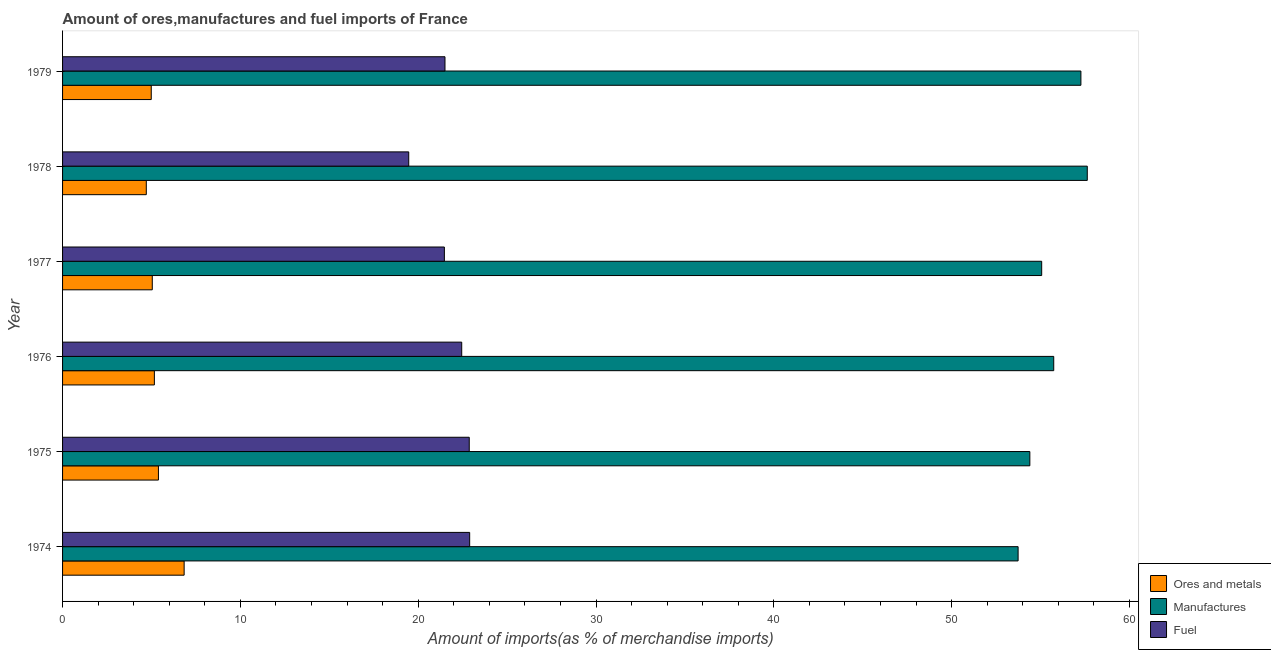How many different coloured bars are there?
Ensure brevity in your answer.  3. Are the number of bars per tick equal to the number of legend labels?
Your answer should be very brief. Yes. Are the number of bars on each tick of the Y-axis equal?
Provide a succinct answer. Yes. What is the label of the 2nd group of bars from the top?
Your answer should be very brief. 1978. What is the percentage of ores and metals imports in 1979?
Ensure brevity in your answer.  4.99. Across all years, what is the maximum percentage of fuel imports?
Provide a succinct answer. 22.89. Across all years, what is the minimum percentage of ores and metals imports?
Your answer should be compact. 4.71. In which year was the percentage of fuel imports maximum?
Make the answer very short. 1974. In which year was the percentage of fuel imports minimum?
Make the answer very short. 1978. What is the total percentage of manufactures imports in the graph?
Your answer should be very brief. 333.82. What is the difference between the percentage of fuel imports in 1977 and that in 1979?
Provide a short and direct response. -0.03. What is the difference between the percentage of fuel imports in 1978 and the percentage of ores and metals imports in 1975?
Give a very brief answer. 14.08. What is the average percentage of ores and metals imports per year?
Provide a short and direct response. 5.36. In the year 1976, what is the difference between the percentage of ores and metals imports and percentage of manufactures imports?
Keep it short and to the point. -50.58. In how many years, is the percentage of fuel imports greater than 52 %?
Ensure brevity in your answer.  0. What is the ratio of the percentage of fuel imports in 1974 to that in 1977?
Provide a short and direct response. 1.07. Is the percentage of ores and metals imports in 1976 less than that in 1979?
Your answer should be compact. No. What is the difference between the highest and the second highest percentage of ores and metals imports?
Provide a succinct answer. 1.45. What is the difference between the highest and the lowest percentage of ores and metals imports?
Keep it short and to the point. 2.13. What does the 2nd bar from the top in 1978 represents?
Make the answer very short. Manufactures. What does the 1st bar from the bottom in 1977 represents?
Your response must be concise. Ores and metals. Is it the case that in every year, the sum of the percentage of ores and metals imports and percentage of manufactures imports is greater than the percentage of fuel imports?
Your answer should be very brief. Yes. How many bars are there?
Offer a very short reply. 18. How many years are there in the graph?
Provide a succinct answer. 6. What is the difference between two consecutive major ticks on the X-axis?
Make the answer very short. 10. Does the graph contain grids?
Make the answer very short. No. How are the legend labels stacked?
Provide a succinct answer. Vertical. What is the title of the graph?
Your response must be concise. Amount of ores,manufactures and fuel imports of France. What is the label or title of the X-axis?
Offer a terse response. Amount of imports(as % of merchandise imports). What is the Amount of imports(as % of merchandise imports) of Ores and metals in 1974?
Give a very brief answer. 6.84. What is the Amount of imports(as % of merchandise imports) of Manufactures in 1974?
Provide a short and direct response. 53.74. What is the Amount of imports(as % of merchandise imports) of Fuel in 1974?
Your answer should be compact. 22.89. What is the Amount of imports(as % of merchandise imports) of Ores and metals in 1975?
Your answer should be very brief. 5.39. What is the Amount of imports(as % of merchandise imports) of Manufactures in 1975?
Make the answer very short. 54.4. What is the Amount of imports(as % of merchandise imports) of Fuel in 1975?
Provide a succinct answer. 22.87. What is the Amount of imports(as % of merchandise imports) of Ores and metals in 1976?
Your response must be concise. 5.16. What is the Amount of imports(as % of merchandise imports) of Manufactures in 1976?
Make the answer very short. 55.74. What is the Amount of imports(as % of merchandise imports) of Fuel in 1976?
Keep it short and to the point. 22.45. What is the Amount of imports(as % of merchandise imports) in Ores and metals in 1977?
Offer a very short reply. 5.05. What is the Amount of imports(as % of merchandise imports) of Manufactures in 1977?
Ensure brevity in your answer.  55.06. What is the Amount of imports(as % of merchandise imports) in Fuel in 1977?
Your answer should be very brief. 21.47. What is the Amount of imports(as % of merchandise imports) in Ores and metals in 1978?
Your answer should be very brief. 4.71. What is the Amount of imports(as % of merchandise imports) of Manufactures in 1978?
Offer a terse response. 57.63. What is the Amount of imports(as % of merchandise imports) in Fuel in 1978?
Ensure brevity in your answer.  19.47. What is the Amount of imports(as % of merchandise imports) in Ores and metals in 1979?
Provide a short and direct response. 4.99. What is the Amount of imports(as % of merchandise imports) of Manufactures in 1979?
Your answer should be very brief. 57.27. What is the Amount of imports(as % of merchandise imports) in Fuel in 1979?
Give a very brief answer. 21.51. Across all years, what is the maximum Amount of imports(as % of merchandise imports) in Ores and metals?
Make the answer very short. 6.84. Across all years, what is the maximum Amount of imports(as % of merchandise imports) in Manufactures?
Make the answer very short. 57.63. Across all years, what is the maximum Amount of imports(as % of merchandise imports) of Fuel?
Make the answer very short. 22.89. Across all years, what is the minimum Amount of imports(as % of merchandise imports) of Ores and metals?
Ensure brevity in your answer.  4.71. Across all years, what is the minimum Amount of imports(as % of merchandise imports) in Manufactures?
Give a very brief answer. 53.74. Across all years, what is the minimum Amount of imports(as % of merchandise imports) in Fuel?
Offer a very short reply. 19.47. What is the total Amount of imports(as % of merchandise imports) in Ores and metals in the graph?
Ensure brevity in your answer.  32.13. What is the total Amount of imports(as % of merchandise imports) of Manufactures in the graph?
Your answer should be very brief. 333.82. What is the total Amount of imports(as % of merchandise imports) of Fuel in the graph?
Offer a terse response. 130.65. What is the difference between the Amount of imports(as % of merchandise imports) in Ores and metals in 1974 and that in 1975?
Provide a short and direct response. 1.45. What is the difference between the Amount of imports(as % of merchandise imports) of Manufactures in 1974 and that in 1975?
Provide a short and direct response. -0.66. What is the difference between the Amount of imports(as % of merchandise imports) of Fuel in 1974 and that in 1975?
Offer a terse response. 0.02. What is the difference between the Amount of imports(as % of merchandise imports) in Ores and metals in 1974 and that in 1976?
Give a very brief answer. 1.67. What is the difference between the Amount of imports(as % of merchandise imports) of Manufactures in 1974 and that in 1976?
Your answer should be compact. -2. What is the difference between the Amount of imports(as % of merchandise imports) of Fuel in 1974 and that in 1976?
Offer a terse response. 0.45. What is the difference between the Amount of imports(as % of merchandise imports) in Ores and metals in 1974 and that in 1977?
Your response must be concise. 1.79. What is the difference between the Amount of imports(as % of merchandise imports) in Manufactures in 1974 and that in 1977?
Your answer should be compact. -1.33. What is the difference between the Amount of imports(as % of merchandise imports) in Fuel in 1974 and that in 1977?
Offer a terse response. 1.42. What is the difference between the Amount of imports(as % of merchandise imports) of Ores and metals in 1974 and that in 1978?
Provide a short and direct response. 2.13. What is the difference between the Amount of imports(as % of merchandise imports) in Manufactures in 1974 and that in 1978?
Offer a terse response. -3.89. What is the difference between the Amount of imports(as % of merchandise imports) in Fuel in 1974 and that in 1978?
Offer a very short reply. 3.43. What is the difference between the Amount of imports(as % of merchandise imports) of Ores and metals in 1974 and that in 1979?
Give a very brief answer. 1.85. What is the difference between the Amount of imports(as % of merchandise imports) in Manufactures in 1974 and that in 1979?
Keep it short and to the point. -3.53. What is the difference between the Amount of imports(as % of merchandise imports) of Fuel in 1974 and that in 1979?
Provide a succinct answer. 1.39. What is the difference between the Amount of imports(as % of merchandise imports) in Ores and metals in 1975 and that in 1976?
Provide a short and direct response. 0.23. What is the difference between the Amount of imports(as % of merchandise imports) of Manufactures in 1975 and that in 1976?
Your response must be concise. -1.34. What is the difference between the Amount of imports(as % of merchandise imports) in Fuel in 1975 and that in 1976?
Your answer should be very brief. 0.42. What is the difference between the Amount of imports(as % of merchandise imports) of Ores and metals in 1975 and that in 1977?
Your response must be concise. 0.35. What is the difference between the Amount of imports(as % of merchandise imports) in Manufactures in 1975 and that in 1977?
Your answer should be very brief. -0.67. What is the difference between the Amount of imports(as % of merchandise imports) of Fuel in 1975 and that in 1977?
Provide a short and direct response. 1.4. What is the difference between the Amount of imports(as % of merchandise imports) of Ores and metals in 1975 and that in 1978?
Your response must be concise. 0.68. What is the difference between the Amount of imports(as % of merchandise imports) of Manufactures in 1975 and that in 1978?
Keep it short and to the point. -3.23. What is the difference between the Amount of imports(as % of merchandise imports) of Fuel in 1975 and that in 1978?
Make the answer very short. 3.4. What is the difference between the Amount of imports(as % of merchandise imports) in Ores and metals in 1975 and that in 1979?
Offer a very short reply. 0.4. What is the difference between the Amount of imports(as % of merchandise imports) in Manufactures in 1975 and that in 1979?
Offer a very short reply. -2.87. What is the difference between the Amount of imports(as % of merchandise imports) of Fuel in 1975 and that in 1979?
Provide a short and direct response. 1.36. What is the difference between the Amount of imports(as % of merchandise imports) in Ores and metals in 1976 and that in 1977?
Provide a succinct answer. 0.12. What is the difference between the Amount of imports(as % of merchandise imports) in Manufactures in 1976 and that in 1977?
Offer a very short reply. 0.68. What is the difference between the Amount of imports(as % of merchandise imports) of Fuel in 1976 and that in 1977?
Ensure brevity in your answer.  0.98. What is the difference between the Amount of imports(as % of merchandise imports) in Ores and metals in 1976 and that in 1978?
Make the answer very short. 0.45. What is the difference between the Amount of imports(as % of merchandise imports) of Manufactures in 1976 and that in 1978?
Provide a succinct answer. -1.89. What is the difference between the Amount of imports(as % of merchandise imports) of Fuel in 1976 and that in 1978?
Your answer should be very brief. 2.98. What is the difference between the Amount of imports(as % of merchandise imports) of Ores and metals in 1976 and that in 1979?
Your answer should be compact. 0.18. What is the difference between the Amount of imports(as % of merchandise imports) of Manufactures in 1976 and that in 1979?
Give a very brief answer. -1.53. What is the difference between the Amount of imports(as % of merchandise imports) in Fuel in 1976 and that in 1979?
Give a very brief answer. 0.94. What is the difference between the Amount of imports(as % of merchandise imports) in Ores and metals in 1977 and that in 1978?
Your answer should be compact. 0.34. What is the difference between the Amount of imports(as % of merchandise imports) of Manufactures in 1977 and that in 1978?
Keep it short and to the point. -2.56. What is the difference between the Amount of imports(as % of merchandise imports) in Fuel in 1977 and that in 1978?
Offer a terse response. 2. What is the difference between the Amount of imports(as % of merchandise imports) of Ores and metals in 1977 and that in 1979?
Ensure brevity in your answer.  0.06. What is the difference between the Amount of imports(as % of merchandise imports) of Manufactures in 1977 and that in 1979?
Offer a very short reply. -2.21. What is the difference between the Amount of imports(as % of merchandise imports) in Fuel in 1977 and that in 1979?
Provide a succinct answer. -0.03. What is the difference between the Amount of imports(as % of merchandise imports) of Ores and metals in 1978 and that in 1979?
Keep it short and to the point. -0.28. What is the difference between the Amount of imports(as % of merchandise imports) in Manufactures in 1978 and that in 1979?
Provide a short and direct response. 0.36. What is the difference between the Amount of imports(as % of merchandise imports) in Fuel in 1978 and that in 1979?
Offer a very short reply. -2.04. What is the difference between the Amount of imports(as % of merchandise imports) of Ores and metals in 1974 and the Amount of imports(as % of merchandise imports) of Manufactures in 1975?
Offer a very short reply. -47.56. What is the difference between the Amount of imports(as % of merchandise imports) in Ores and metals in 1974 and the Amount of imports(as % of merchandise imports) in Fuel in 1975?
Make the answer very short. -16.03. What is the difference between the Amount of imports(as % of merchandise imports) of Manufactures in 1974 and the Amount of imports(as % of merchandise imports) of Fuel in 1975?
Offer a terse response. 30.87. What is the difference between the Amount of imports(as % of merchandise imports) in Ores and metals in 1974 and the Amount of imports(as % of merchandise imports) in Manufactures in 1976?
Offer a terse response. -48.9. What is the difference between the Amount of imports(as % of merchandise imports) in Ores and metals in 1974 and the Amount of imports(as % of merchandise imports) in Fuel in 1976?
Keep it short and to the point. -15.61. What is the difference between the Amount of imports(as % of merchandise imports) of Manufactures in 1974 and the Amount of imports(as % of merchandise imports) of Fuel in 1976?
Keep it short and to the point. 31.29. What is the difference between the Amount of imports(as % of merchandise imports) in Ores and metals in 1974 and the Amount of imports(as % of merchandise imports) in Manufactures in 1977?
Offer a very short reply. -48.22. What is the difference between the Amount of imports(as % of merchandise imports) in Ores and metals in 1974 and the Amount of imports(as % of merchandise imports) in Fuel in 1977?
Your response must be concise. -14.63. What is the difference between the Amount of imports(as % of merchandise imports) in Manufactures in 1974 and the Amount of imports(as % of merchandise imports) in Fuel in 1977?
Your answer should be compact. 32.26. What is the difference between the Amount of imports(as % of merchandise imports) in Ores and metals in 1974 and the Amount of imports(as % of merchandise imports) in Manufactures in 1978?
Offer a terse response. -50.79. What is the difference between the Amount of imports(as % of merchandise imports) in Ores and metals in 1974 and the Amount of imports(as % of merchandise imports) in Fuel in 1978?
Your response must be concise. -12.63. What is the difference between the Amount of imports(as % of merchandise imports) in Manufactures in 1974 and the Amount of imports(as % of merchandise imports) in Fuel in 1978?
Your response must be concise. 34.27. What is the difference between the Amount of imports(as % of merchandise imports) of Ores and metals in 1974 and the Amount of imports(as % of merchandise imports) of Manufactures in 1979?
Make the answer very short. -50.43. What is the difference between the Amount of imports(as % of merchandise imports) of Ores and metals in 1974 and the Amount of imports(as % of merchandise imports) of Fuel in 1979?
Give a very brief answer. -14.67. What is the difference between the Amount of imports(as % of merchandise imports) of Manufactures in 1974 and the Amount of imports(as % of merchandise imports) of Fuel in 1979?
Provide a succinct answer. 32.23. What is the difference between the Amount of imports(as % of merchandise imports) of Ores and metals in 1975 and the Amount of imports(as % of merchandise imports) of Manufactures in 1976?
Make the answer very short. -50.35. What is the difference between the Amount of imports(as % of merchandise imports) in Ores and metals in 1975 and the Amount of imports(as % of merchandise imports) in Fuel in 1976?
Your response must be concise. -17.06. What is the difference between the Amount of imports(as % of merchandise imports) in Manufactures in 1975 and the Amount of imports(as % of merchandise imports) in Fuel in 1976?
Your response must be concise. 31.95. What is the difference between the Amount of imports(as % of merchandise imports) in Ores and metals in 1975 and the Amount of imports(as % of merchandise imports) in Manufactures in 1977?
Your answer should be compact. -49.67. What is the difference between the Amount of imports(as % of merchandise imports) in Ores and metals in 1975 and the Amount of imports(as % of merchandise imports) in Fuel in 1977?
Keep it short and to the point. -16.08. What is the difference between the Amount of imports(as % of merchandise imports) of Manufactures in 1975 and the Amount of imports(as % of merchandise imports) of Fuel in 1977?
Make the answer very short. 32.92. What is the difference between the Amount of imports(as % of merchandise imports) in Ores and metals in 1975 and the Amount of imports(as % of merchandise imports) in Manufactures in 1978?
Make the answer very short. -52.23. What is the difference between the Amount of imports(as % of merchandise imports) of Ores and metals in 1975 and the Amount of imports(as % of merchandise imports) of Fuel in 1978?
Keep it short and to the point. -14.08. What is the difference between the Amount of imports(as % of merchandise imports) in Manufactures in 1975 and the Amount of imports(as % of merchandise imports) in Fuel in 1978?
Offer a terse response. 34.93. What is the difference between the Amount of imports(as % of merchandise imports) in Ores and metals in 1975 and the Amount of imports(as % of merchandise imports) in Manufactures in 1979?
Your response must be concise. -51.88. What is the difference between the Amount of imports(as % of merchandise imports) in Ores and metals in 1975 and the Amount of imports(as % of merchandise imports) in Fuel in 1979?
Offer a very short reply. -16.11. What is the difference between the Amount of imports(as % of merchandise imports) of Manufactures in 1975 and the Amount of imports(as % of merchandise imports) of Fuel in 1979?
Give a very brief answer. 32.89. What is the difference between the Amount of imports(as % of merchandise imports) in Ores and metals in 1976 and the Amount of imports(as % of merchandise imports) in Manufactures in 1977?
Keep it short and to the point. -49.9. What is the difference between the Amount of imports(as % of merchandise imports) in Ores and metals in 1976 and the Amount of imports(as % of merchandise imports) in Fuel in 1977?
Keep it short and to the point. -16.31. What is the difference between the Amount of imports(as % of merchandise imports) in Manufactures in 1976 and the Amount of imports(as % of merchandise imports) in Fuel in 1977?
Your answer should be compact. 34.27. What is the difference between the Amount of imports(as % of merchandise imports) of Ores and metals in 1976 and the Amount of imports(as % of merchandise imports) of Manufactures in 1978?
Your answer should be compact. -52.46. What is the difference between the Amount of imports(as % of merchandise imports) in Ores and metals in 1976 and the Amount of imports(as % of merchandise imports) in Fuel in 1978?
Ensure brevity in your answer.  -14.3. What is the difference between the Amount of imports(as % of merchandise imports) in Manufactures in 1976 and the Amount of imports(as % of merchandise imports) in Fuel in 1978?
Ensure brevity in your answer.  36.27. What is the difference between the Amount of imports(as % of merchandise imports) of Ores and metals in 1976 and the Amount of imports(as % of merchandise imports) of Manufactures in 1979?
Your answer should be compact. -52.1. What is the difference between the Amount of imports(as % of merchandise imports) in Ores and metals in 1976 and the Amount of imports(as % of merchandise imports) in Fuel in 1979?
Your answer should be very brief. -16.34. What is the difference between the Amount of imports(as % of merchandise imports) in Manufactures in 1976 and the Amount of imports(as % of merchandise imports) in Fuel in 1979?
Your answer should be very brief. 34.23. What is the difference between the Amount of imports(as % of merchandise imports) of Ores and metals in 1977 and the Amount of imports(as % of merchandise imports) of Manufactures in 1978?
Ensure brevity in your answer.  -52.58. What is the difference between the Amount of imports(as % of merchandise imports) of Ores and metals in 1977 and the Amount of imports(as % of merchandise imports) of Fuel in 1978?
Your answer should be compact. -14.42. What is the difference between the Amount of imports(as % of merchandise imports) of Manufactures in 1977 and the Amount of imports(as % of merchandise imports) of Fuel in 1978?
Your answer should be very brief. 35.59. What is the difference between the Amount of imports(as % of merchandise imports) of Ores and metals in 1977 and the Amount of imports(as % of merchandise imports) of Manufactures in 1979?
Make the answer very short. -52.22. What is the difference between the Amount of imports(as % of merchandise imports) of Ores and metals in 1977 and the Amount of imports(as % of merchandise imports) of Fuel in 1979?
Give a very brief answer. -16.46. What is the difference between the Amount of imports(as % of merchandise imports) in Manufactures in 1977 and the Amount of imports(as % of merchandise imports) in Fuel in 1979?
Offer a terse response. 33.56. What is the difference between the Amount of imports(as % of merchandise imports) of Ores and metals in 1978 and the Amount of imports(as % of merchandise imports) of Manufactures in 1979?
Make the answer very short. -52.56. What is the difference between the Amount of imports(as % of merchandise imports) in Ores and metals in 1978 and the Amount of imports(as % of merchandise imports) in Fuel in 1979?
Make the answer very short. -16.8. What is the difference between the Amount of imports(as % of merchandise imports) of Manufactures in 1978 and the Amount of imports(as % of merchandise imports) of Fuel in 1979?
Ensure brevity in your answer.  36.12. What is the average Amount of imports(as % of merchandise imports) of Ores and metals per year?
Ensure brevity in your answer.  5.36. What is the average Amount of imports(as % of merchandise imports) of Manufactures per year?
Your answer should be compact. 55.64. What is the average Amount of imports(as % of merchandise imports) in Fuel per year?
Your response must be concise. 21.78. In the year 1974, what is the difference between the Amount of imports(as % of merchandise imports) in Ores and metals and Amount of imports(as % of merchandise imports) in Manufactures?
Offer a very short reply. -46.9. In the year 1974, what is the difference between the Amount of imports(as % of merchandise imports) in Ores and metals and Amount of imports(as % of merchandise imports) in Fuel?
Offer a very short reply. -16.06. In the year 1974, what is the difference between the Amount of imports(as % of merchandise imports) of Manufactures and Amount of imports(as % of merchandise imports) of Fuel?
Your response must be concise. 30.84. In the year 1975, what is the difference between the Amount of imports(as % of merchandise imports) of Ores and metals and Amount of imports(as % of merchandise imports) of Manufactures?
Your answer should be compact. -49. In the year 1975, what is the difference between the Amount of imports(as % of merchandise imports) of Ores and metals and Amount of imports(as % of merchandise imports) of Fuel?
Give a very brief answer. -17.48. In the year 1975, what is the difference between the Amount of imports(as % of merchandise imports) of Manufactures and Amount of imports(as % of merchandise imports) of Fuel?
Keep it short and to the point. 31.53. In the year 1976, what is the difference between the Amount of imports(as % of merchandise imports) of Ores and metals and Amount of imports(as % of merchandise imports) of Manufactures?
Give a very brief answer. -50.58. In the year 1976, what is the difference between the Amount of imports(as % of merchandise imports) in Ores and metals and Amount of imports(as % of merchandise imports) in Fuel?
Provide a succinct answer. -17.28. In the year 1976, what is the difference between the Amount of imports(as % of merchandise imports) in Manufactures and Amount of imports(as % of merchandise imports) in Fuel?
Your answer should be compact. 33.29. In the year 1977, what is the difference between the Amount of imports(as % of merchandise imports) in Ores and metals and Amount of imports(as % of merchandise imports) in Manufactures?
Your answer should be compact. -50.02. In the year 1977, what is the difference between the Amount of imports(as % of merchandise imports) of Ores and metals and Amount of imports(as % of merchandise imports) of Fuel?
Your answer should be very brief. -16.43. In the year 1977, what is the difference between the Amount of imports(as % of merchandise imports) in Manufactures and Amount of imports(as % of merchandise imports) in Fuel?
Provide a succinct answer. 33.59. In the year 1978, what is the difference between the Amount of imports(as % of merchandise imports) in Ores and metals and Amount of imports(as % of merchandise imports) in Manufactures?
Ensure brevity in your answer.  -52.92. In the year 1978, what is the difference between the Amount of imports(as % of merchandise imports) of Ores and metals and Amount of imports(as % of merchandise imports) of Fuel?
Offer a terse response. -14.76. In the year 1978, what is the difference between the Amount of imports(as % of merchandise imports) of Manufactures and Amount of imports(as % of merchandise imports) of Fuel?
Offer a very short reply. 38.16. In the year 1979, what is the difference between the Amount of imports(as % of merchandise imports) of Ores and metals and Amount of imports(as % of merchandise imports) of Manufactures?
Make the answer very short. -52.28. In the year 1979, what is the difference between the Amount of imports(as % of merchandise imports) in Ores and metals and Amount of imports(as % of merchandise imports) in Fuel?
Your answer should be compact. -16.52. In the year 1979, what is the difference between the Amount of imports(as % of merchandise imports) in Manufactures and Amount of imports(as % of merchandise imports) in Fuel?
Your answer should be very brief. 35.76. What is the ratio of the Amount of imports(as % of merchandise imports) in Ores and metals in 1974 to that in 1975?
Your answer should be compact. 1.27. What is the ratio of the Amount of imports(as % of merchandise imports) of Manufactures in 1974 to that in 1975?
Make the answer very short. 0.99. What is the ratio of the Amount of imports(as % of merchandise imports) in Ores and metals in 1974 to that in 1976?
Ensure brevity in your answer.  1.32. What is the ratio of the Amount of imports(as % of merchandise imports) in Manufactures in 1974 to that in 1976?
Your answer should be very brief. 0.96. What is the ratio of the Amount of imports(as % of merchandise imports) of Fuel in 1974 to that in 1976?
Your answer should be very brief. 1.02. What is the ratio of the Amount of imports(as % of merchandise imports) in Ores and metals in 1974 to that in 1977?
Give a very brief answer. 1.35. What is the ratio of the Amount of imports(as % of merchandise imports) of Manufactures in 1974 to that in 1977?
Offer a very short reply. 0.98. What is the ratio of the Amount of imports(as % of merchandise imports) of Fuel in 1974 to that in 1977?
Give a very brief answer. 1.07. What is the ratio of the Amount of imports(as % of merchandise imports) in Ores and metals in 1974 to that in 1978?
Offer a terse response. 1.45. What is the ratio of the Amount of imports(as % of merchandise imports) of Manufactures in 1974 to that in 1978?
Give a very brief answer. 0.93. What is the ratio of the Amount of imports(as % of merchandise imports) in Fuel in 1974 to that in 1978?
Provide a short and direct response. 1.18. What is the ratio of the Amount of imports(as % of merchandise imports) in Ores and metals in 1974 to that in 1979?
Offer a very short reply. 1.37. What is the ratio of the Amount of imports(as % of merchandise imports) of Manufactures in 1974 to that in 1979?
Offer a very short reply. 0.94. What is the ratio of the Amount of imports(as % of merchandise imports) of Fuel in 1974 to that in 1979?
Your answer should be very brief. 1.06. What is the ratio of the Amount of imports(as % of merchandise imports) of Ores and metals in 1975 to that in 1976?
Make the answer very short. 1.04. What is the ratio of the Amount of imports(as % of merchandise imports) in Manufactures in 1975 to that in 1976?
Your answer should be compact. 0.98. What is the ratio of the Amount of imports(as % of merchandise imports) in Fuel in 1975 to that in 1976?
Offer a very short reply. 1.02. What is the ratio of the Amount of imports(as % of merchandise imports) of Ores and metals in 1975 to that in 1977?
Make the answer very short. 1.07. What is the ratio of the Amount of imports(as % of merchandise imports) in Manufactures in 1975 to that in 1977?
Give a very brief answer. 0.99. What is the ratio of the Amount of imports(as % of merchandise imports) of Fuel in 1975 to that in 1977?
Your answer should be compact. 1.07. What is the ratio of the Amount of imports(as % of merchandise imports) of Ores and metals in 1975 to that in 1978?
Your answer should be compact. 1.14. What is the ratio of the Amount of imports(as % of merchandise imports) of Manufactures in 1975 to that in 1978?
Offer a terse response. 0.94. What is the ratio of the Amount of imports(as % of merchandise imports) in Fuel in 1975 to that in 1978?
Your answer should be compact. 1.17. What is the ratio of the Amount of imports(as % of merchandise imports) in Ores and metals in 1975 to that in 1979?
Your answer should be very brief. 1.08. What is the ratio of the Amount of imports(as % of merchandise imports) in Manufactures in 1975 to that in 1979?
Keep it short and to the point. 0.95. What is the ratio of the Amount of imports(as % of merchandise imports) in Fuel in 1975 to that in 1979?
Your response must be concise. 1.06. What is the ratio of the Amount of imports(as % of merchandise imports) of Ores and metals in 1976 to that in 1977?
Your response must be concise. 1.02. What is the ratio of the Amount of imports(as % of merchandise imports) of Manufactures in 1976 to that in 1977?
Make the answer very short. 1.01. What is the ratio of the Amount of imports(as % of merchandise imports) of Fuel in 1976 to that in 1977?
Keep it short and to the point. 1.05. What is the ratio of the Amount of imports(as % of merchandise imports) of Ores and metals in 1976 to that in 1978?
Ensure brevity in your answer.  1.1. What is the ratio of the Amount of imports(as % of merchandise imports) in Manufactures in 1976 to that in 1978?
Your answer should be very brief. 0.97. What is the ratio of the Amount of imports(as % of merchandise imports) in Fuel in 1976 to that in 1978?
Ensure brevity in your answer.  1.15. What is the ratio of the Amount of imports(as % of merchandise imports) in Ores and metals in 1976 to that in 1979?
Your response must be concise. 1.04. What is the ratio of the Amount of imports(as % of merchandise imports) in Manufactures in 1976 to that in 1979?
Offer a very short reply. 0.97. What is the ratio of the Amount of imports(as % of merchandise imports) in Fuel in 1976 to that in 1979?
Keep it short and to the point. 1.04. What is the ratio of the Amount of imports(as % of merchandise imports) in Ores and metals in 1977 to that in 1978?
Ensure brevity in your answer.  1.07. What is the ratio of the Amount of imports(as % of merchandise imports) of Manufactures in 1977 to that in 1978?
Ensure brevity in your answer.  0.96. What is the ratio of the Amount of imports(as % of merchandise imports) in Fuel in 1977 to that in 1978?
Give a very brief answer. 1.1. What is the ratio of the Amount of imports(as % of merchandise imports) in Ores and metals in 1977 to that in 1979?
Keep it short and to the point. 1.01. What is the ratio of the Amount of imports(as % of merchandise imports) of Manufactures in 1977 to that in 1979?
Your response must be concise. 0.96. What is the ratio of the Amount of imports(as % of merchandise imports) in Fuel in 1977 to that in 1979?
Keep it short and to the point. 1. What is the ratio of the Amount of imports(as % of merchandise imports) in Ores and metals in 1978 to that in 1979?
Provide a succinct answer. 0.94. What is the ratio of the Amount of imports(as % of merchandise imports) in Fuel in 1978 to that in 1979?
Provide a succinct answer. 0.91. What is the difference between the highest and the second highest Amount of imports(as % of merchandise imports) in Ores and metals?
Offer a very short reply. 1.45. What is the difference between the highest and the second highest Amount of imports(as % of merchandise imports) in Manufactures?
Offer a very short reply. 0.36. What is the difference between the highest and the second highest Amount of imports(as % of merchandise imports) in Fuel?
Give a very brief answer. 0.02. What is the difference between the highest and the lowest Amount of imports(as % of merchandise imports) in Ores and metals?
Offer a very short reply. 2.13. What is the difference between the highest and the lowest Amount of imports(as % of merchandise imports) in Manufactures?
Make the answer very short. 3.89. What is the difference between the highest and the lowest Amount of imports(as % of merchandise imports) of Fuel?
Ensure brevity in your answer.  3.43. 